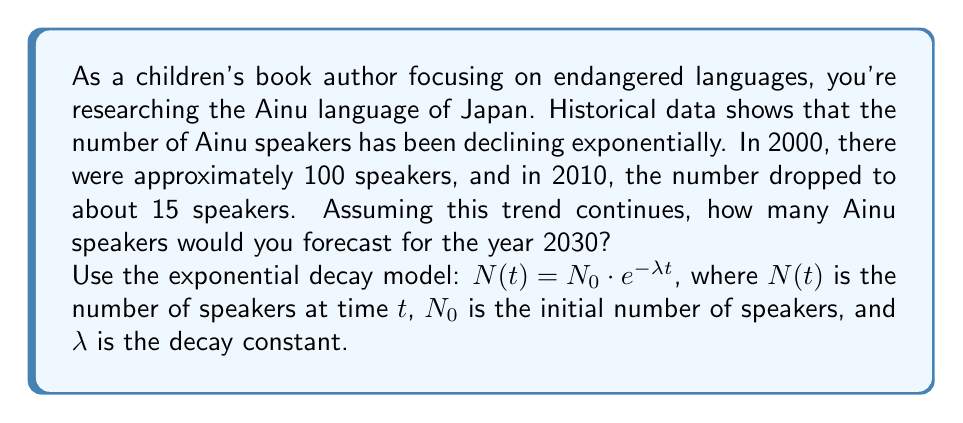Show me your answer to this math problem. To solve this problem, we'll follow these steps:

1) First, we need to find the decay constant $\lambda$ using the given data points:
   $N(0) = 100$ (in 2000)
   $N(10) = 15$ (in 2010)

2) We can use the exponential decay formula:
   $15 = 100 \cdot e^{-\lambda \cdot 10}$

3) Solving for $\lambda$:
   $\frac{15}{100} = e^{-10\lambda}$
   $\ln(\frac{15}{100}) = -10\lambda$
   $\lambda = -\frac{1}{10}\ln(\frac{15}{100}) \approx 0.1897$

4) Now that we have $\lambda$, we can forecast the number of speakers in 2030, which is 30 years from our initial point in 2000:

   $N(30) = 100 \cdot e^{-0.1897 \cdot 30}$

5) Calculating this:
   $N(30) = 100 \cdot e^{-5.691} \approx 0.3378$

6) Since we can't have a fractional number of speakers, we round down to the nearest whole number.
Answer: The forecast predicts 0 Ainu speakers by 2030, based on the exponential decay model. 